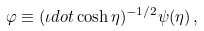<formula> <loc_0><loc_0><loc_500><loc_500>\varphi \equiv ( \iota d o t \cosh \eta ) ^ { - 1 / 2 } \psi ( \eta ) \, ,</formula> 